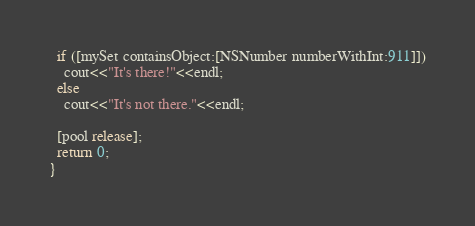<code> <loc_0><loc_0><loc_500><loc_500><_ObjectiveC_>  if ([mySet containsObject:[NSNumber numberWithInt:911]])
    cout<<"It's there!"<<endl;
  else
    cout<<"It's not there."<<endl;

  [pool release];
  return 0;
}
</code> 